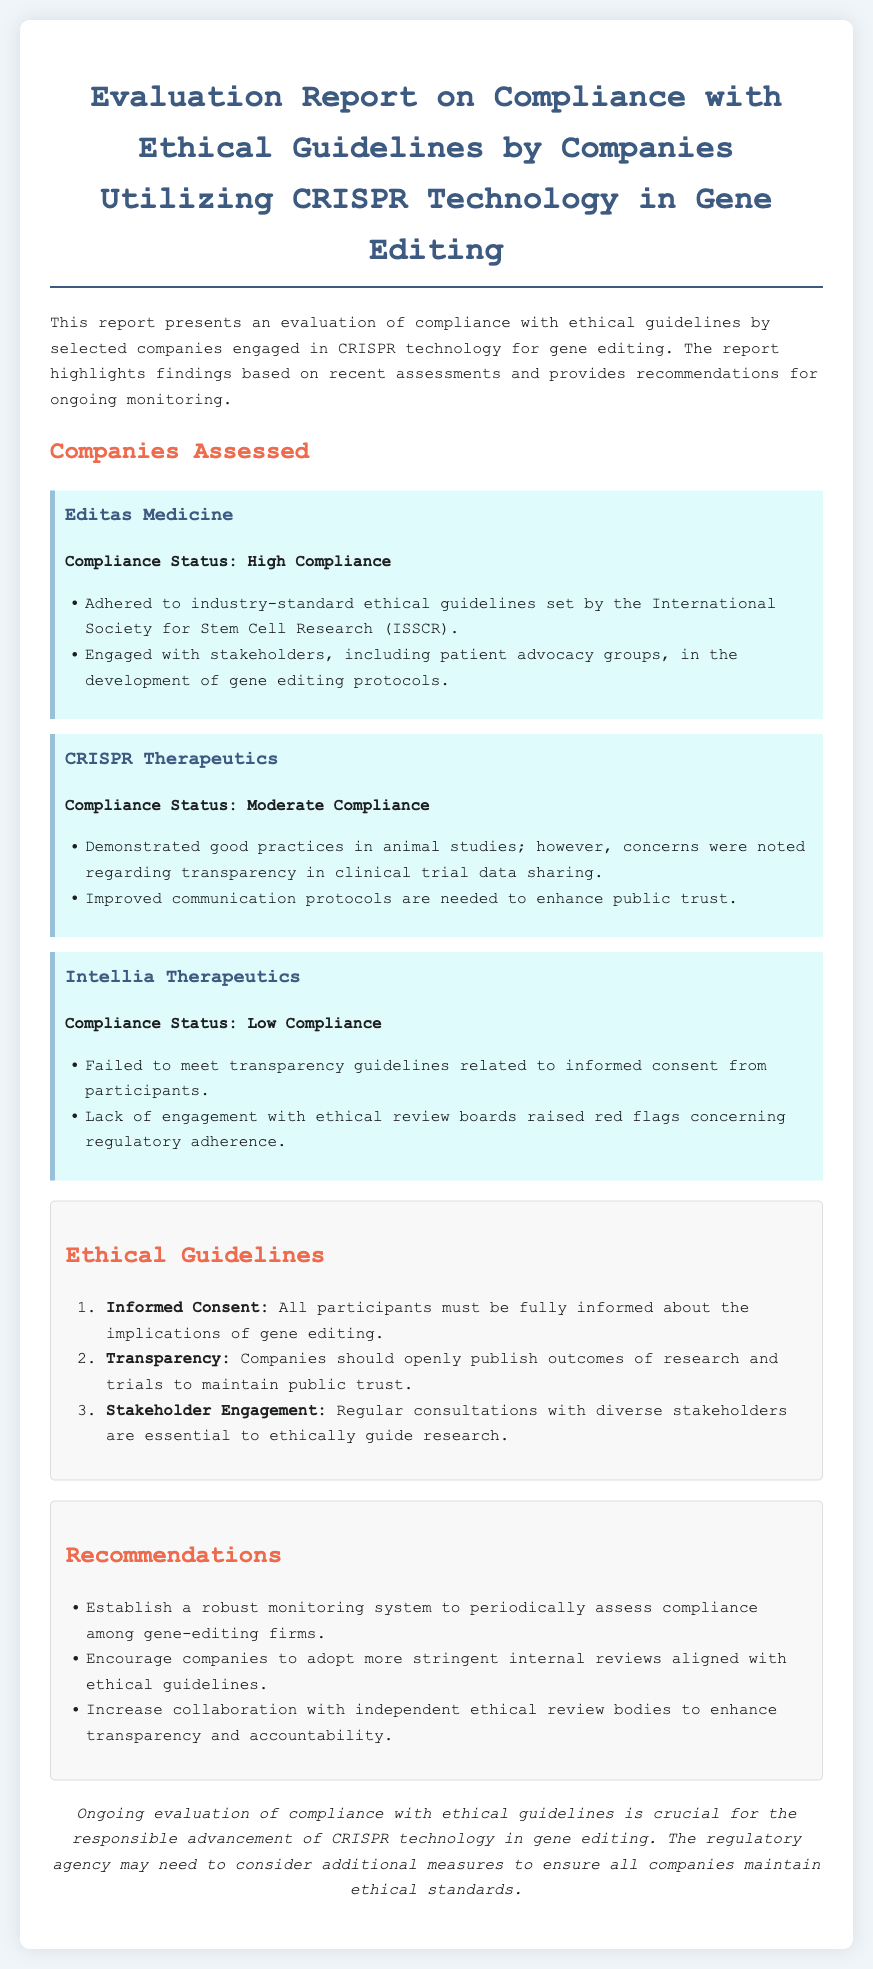What is the title of the report? The title of the report is stated at the top of the document, which outlines the subject of the evaluation.
Answer: Evaluation Report on Compliance with Ethical Guidelines by Companies Utilizing CRISPR Technology in Gene Editing Which company achieved high compliance? The document states the compliance status of each company assessed, highlighting their level of adherence to ethical guidelines.
Answer: Editas Medicine What was noted as a concern for CRISPR Therapeutics? The report lists specific compliance issues for each company, focusing on what was lacking or needed improvement.
Answer: Transparency in clinical trial data sharing What is one of the ethical guidelines mentioned? The ethical guidelines are outlined in a numbered list within the document, specifying the expectations for companies in gene editing.
Answer: Informed Consent How many companies were assessed in the report? The report addresses three companies, and the list of companies provides the basis for understanding the scope of the assessment.
Answer: Three What is a recommendation given in the report? The recommendations section includes strategies for improving compliance and ethical standards among the assessed companies.
Answer: Establish a robust monitoring system What is the compliance status of Intellia Therapeutics? The document provides specific compliance statuses for each assessed company, indicating their level of adherence to ethical guidelines.
Answer: Low Compliance Which organization’s guidelines did Editas Medicine adhere to? The report mentions adherence to specific ethical guidelines and identifies the organization behind those guidelines for each company.
Answer: International Society for Stem Cell Research (ISSCR) 